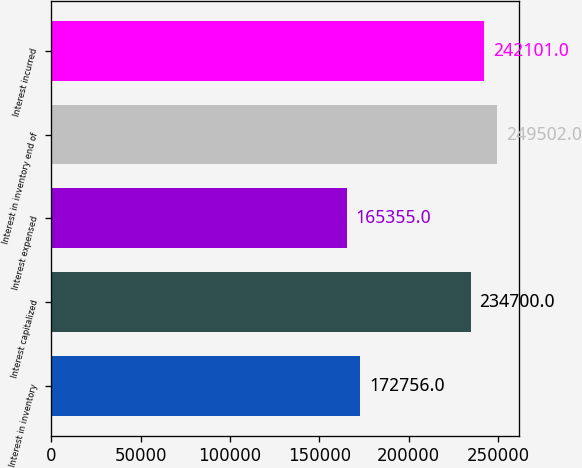Convert chart to OTSL. <chart><loc_0><loc_0><loc_500><loc_500><bar_chart><fcel>Interest in inventory<fcel>Interest capitalized<fcel>Interest expensed<fcel>Interest in inventory end of<fcel>Interest incurred<nl><fcel>172756<fcel>234700<fcel>165355<fcel>249502<fcel>242101<nl></chart> 